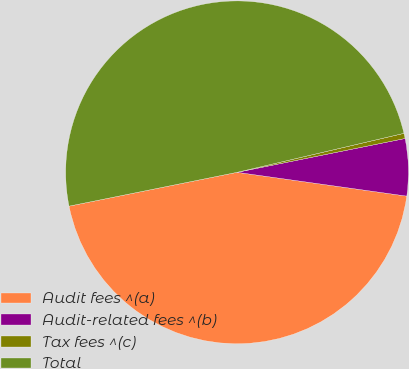Convert chart to OTSL. <chart><loc_0><loc_0><loc_500><loc_500><pie_chart><fcel>Audit fees ^(a)<fcel>Audit-related fees ^(b)<fcel>Tax fees ^(c)<fcel>Total<nl><fcel>44.62%<fcel>5.38%<fcel>0.49%<fcel>49.51%<nl></chart> 